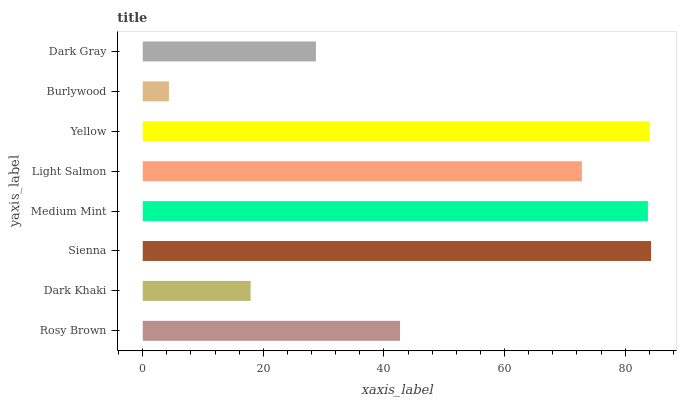Is Burlywood the minimum?
Answer yes or no. Yes. Is Sienna the maximum?
Answer yes or no. Yes. Is Dark Khaki the minimum?
Answer yes or no. No. Is Dark Khaki the maximum?
Answer yes or no. No. Is Rosy Brown greater than Dark Khaki?
Answer yes or no. Yes. Is Dark Khaki less than Rosy Brown?
Answer yes or no. Yes. Is Dark Khaki greater than Rosy Brown?
Answer yes or no. No. Is Rosy Brown less than Dark Khaki?
Answer yes or no. No. Is Light Salmon the high median?
Answer yes or no. Yes. Is Rosy Brown the low median?
Answer yes or no. Yes. Is Yellow the high median?
Answer yes or no. No. Is Dark Gray the low median?
Answer yes or no. No. 